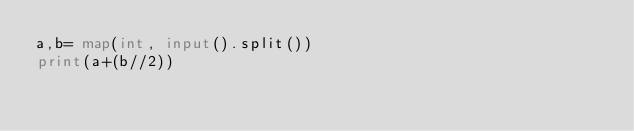Convert code to text. <code><loc_0><loc_0><loc_500><loc_500><_Python_>a,b= map(int, input().split())
print(a+(b//2))</code> 